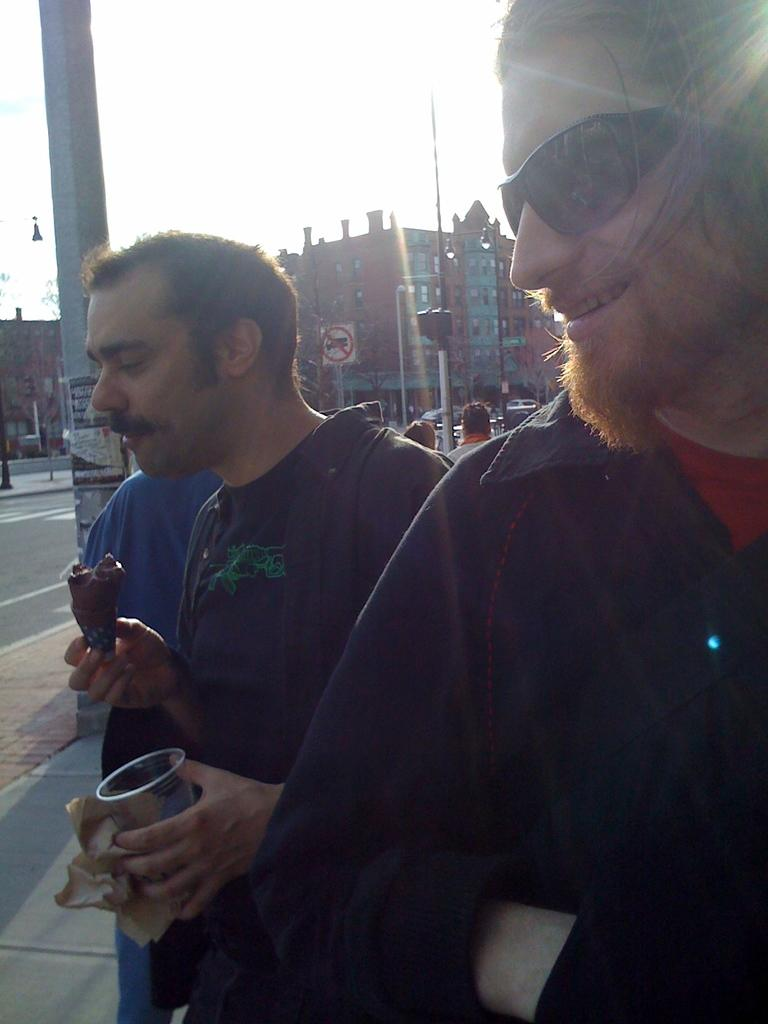How many people are in the image? There are two men standing in the image. What can be seen in the background of the image? There are buildings visible in the image. What is attached to the pole in the image? There is a sign board attached to the pole. What are the men holding in the image? One man is holding a food item, and the other man is holding a glass. Can you see any cobwebs on the pole in the image? There is no mention of cobwebs in the image, so we cannot determine if they are present or not. Are there any beetles crawling on the food item held by one of the men? There is no mention of beetles in the image, so we cannot determine if they are present or not. 